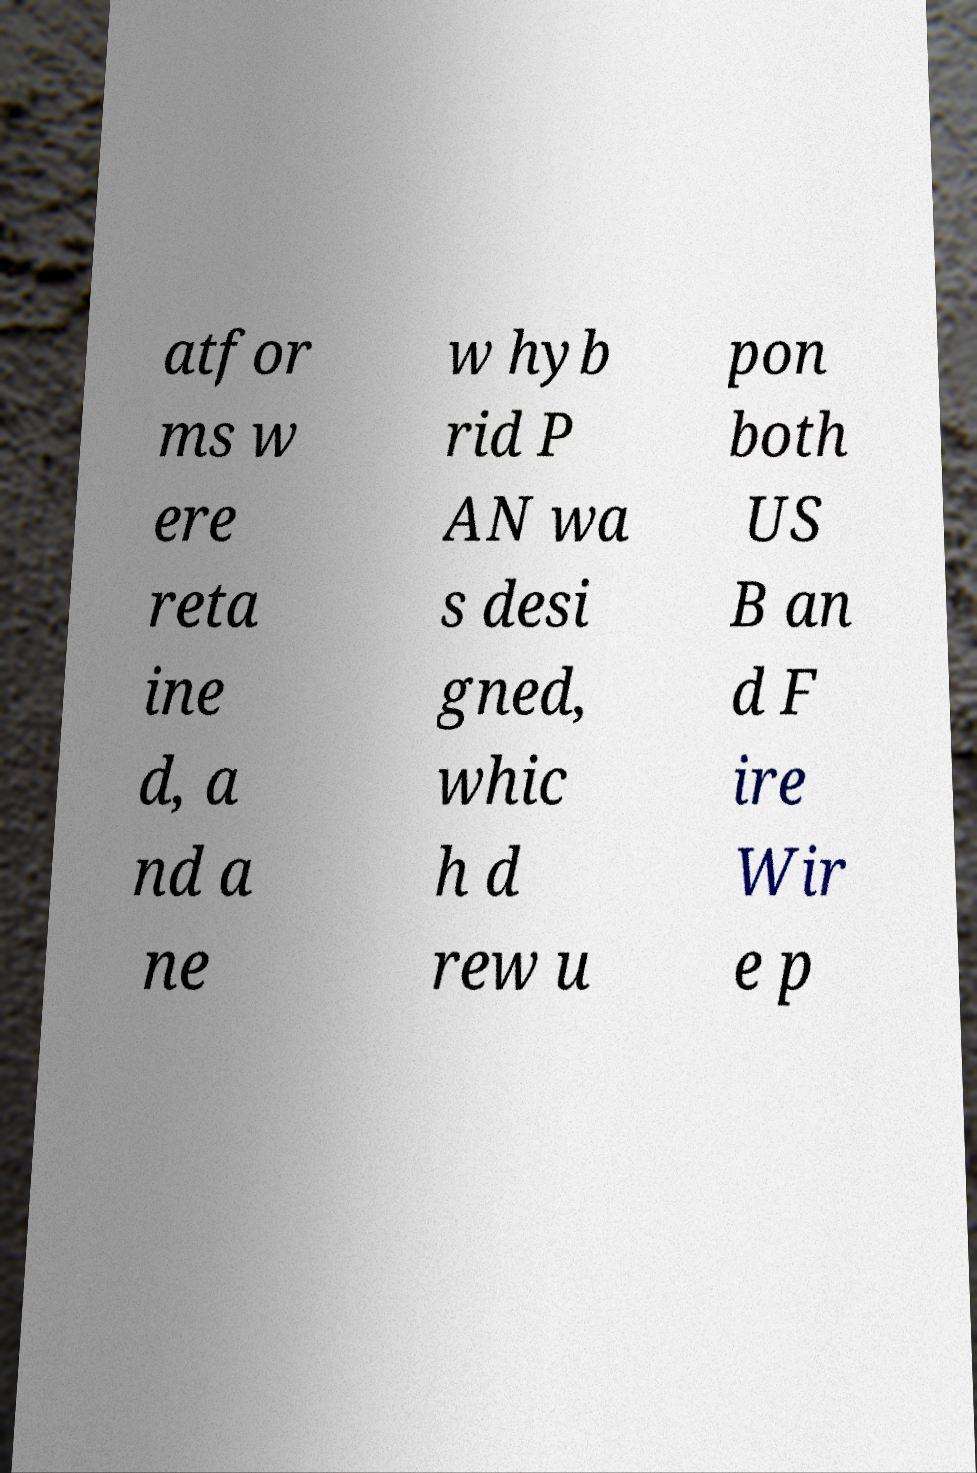There's text embedded in this image that I need extracted. Can you transcribe it verbatim? atfor ms w ere reta ine d, a nd a ne w hyb rid P AN wa s desi gned, whic h d rew u pon both US B an d F ire Wir e p 